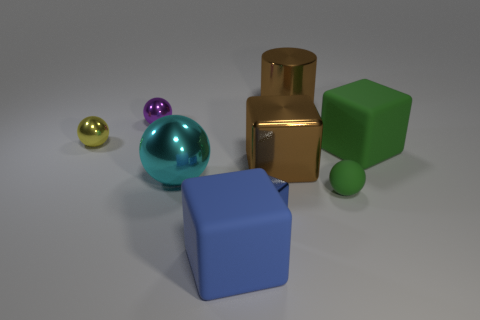Subtract all big blue blocks. How many blocks are left? 3 Subtract all yellow spheres. How many blue cubes are left? 2 Add 1 large green spheres. How many objects exist? 10 Subtract all blue cubes. How many cubes are left? 2 Subtract all cylinders. How many objects are left? 8 Subtract 1 balls. How many balls are left? 3 Add 4 blocks. How many blocks are left? 8 Add 3 small green cylinders. How many small green cylinders exist? 3 Subtract 0 green cylinders. How many objects are left? 9 Subtract all purple spheres. Subtract all red cubes. How many spheres are left? 3 